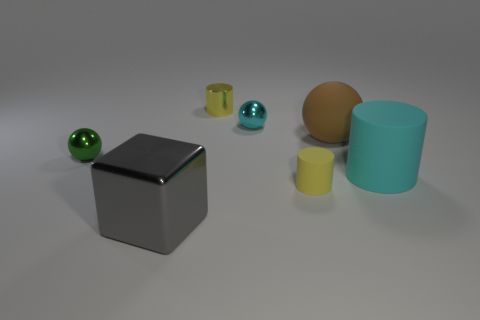Can you describe what the atmosphere or mood of this image might be? The image has a minimalist and sterile atmosphere, with muted colors and a clean background, conveying a sense of calmness and simplicity. 